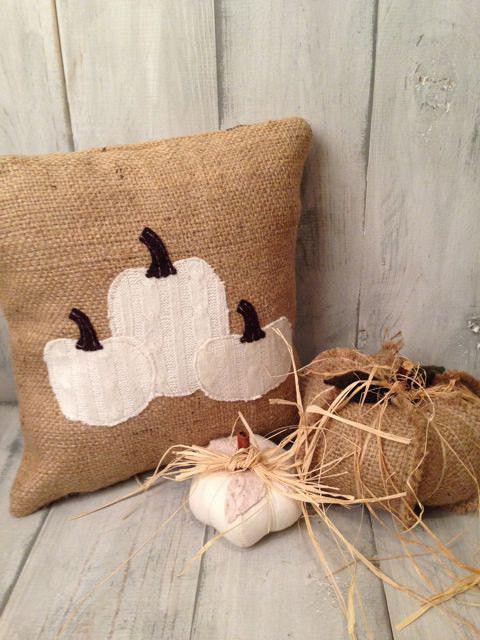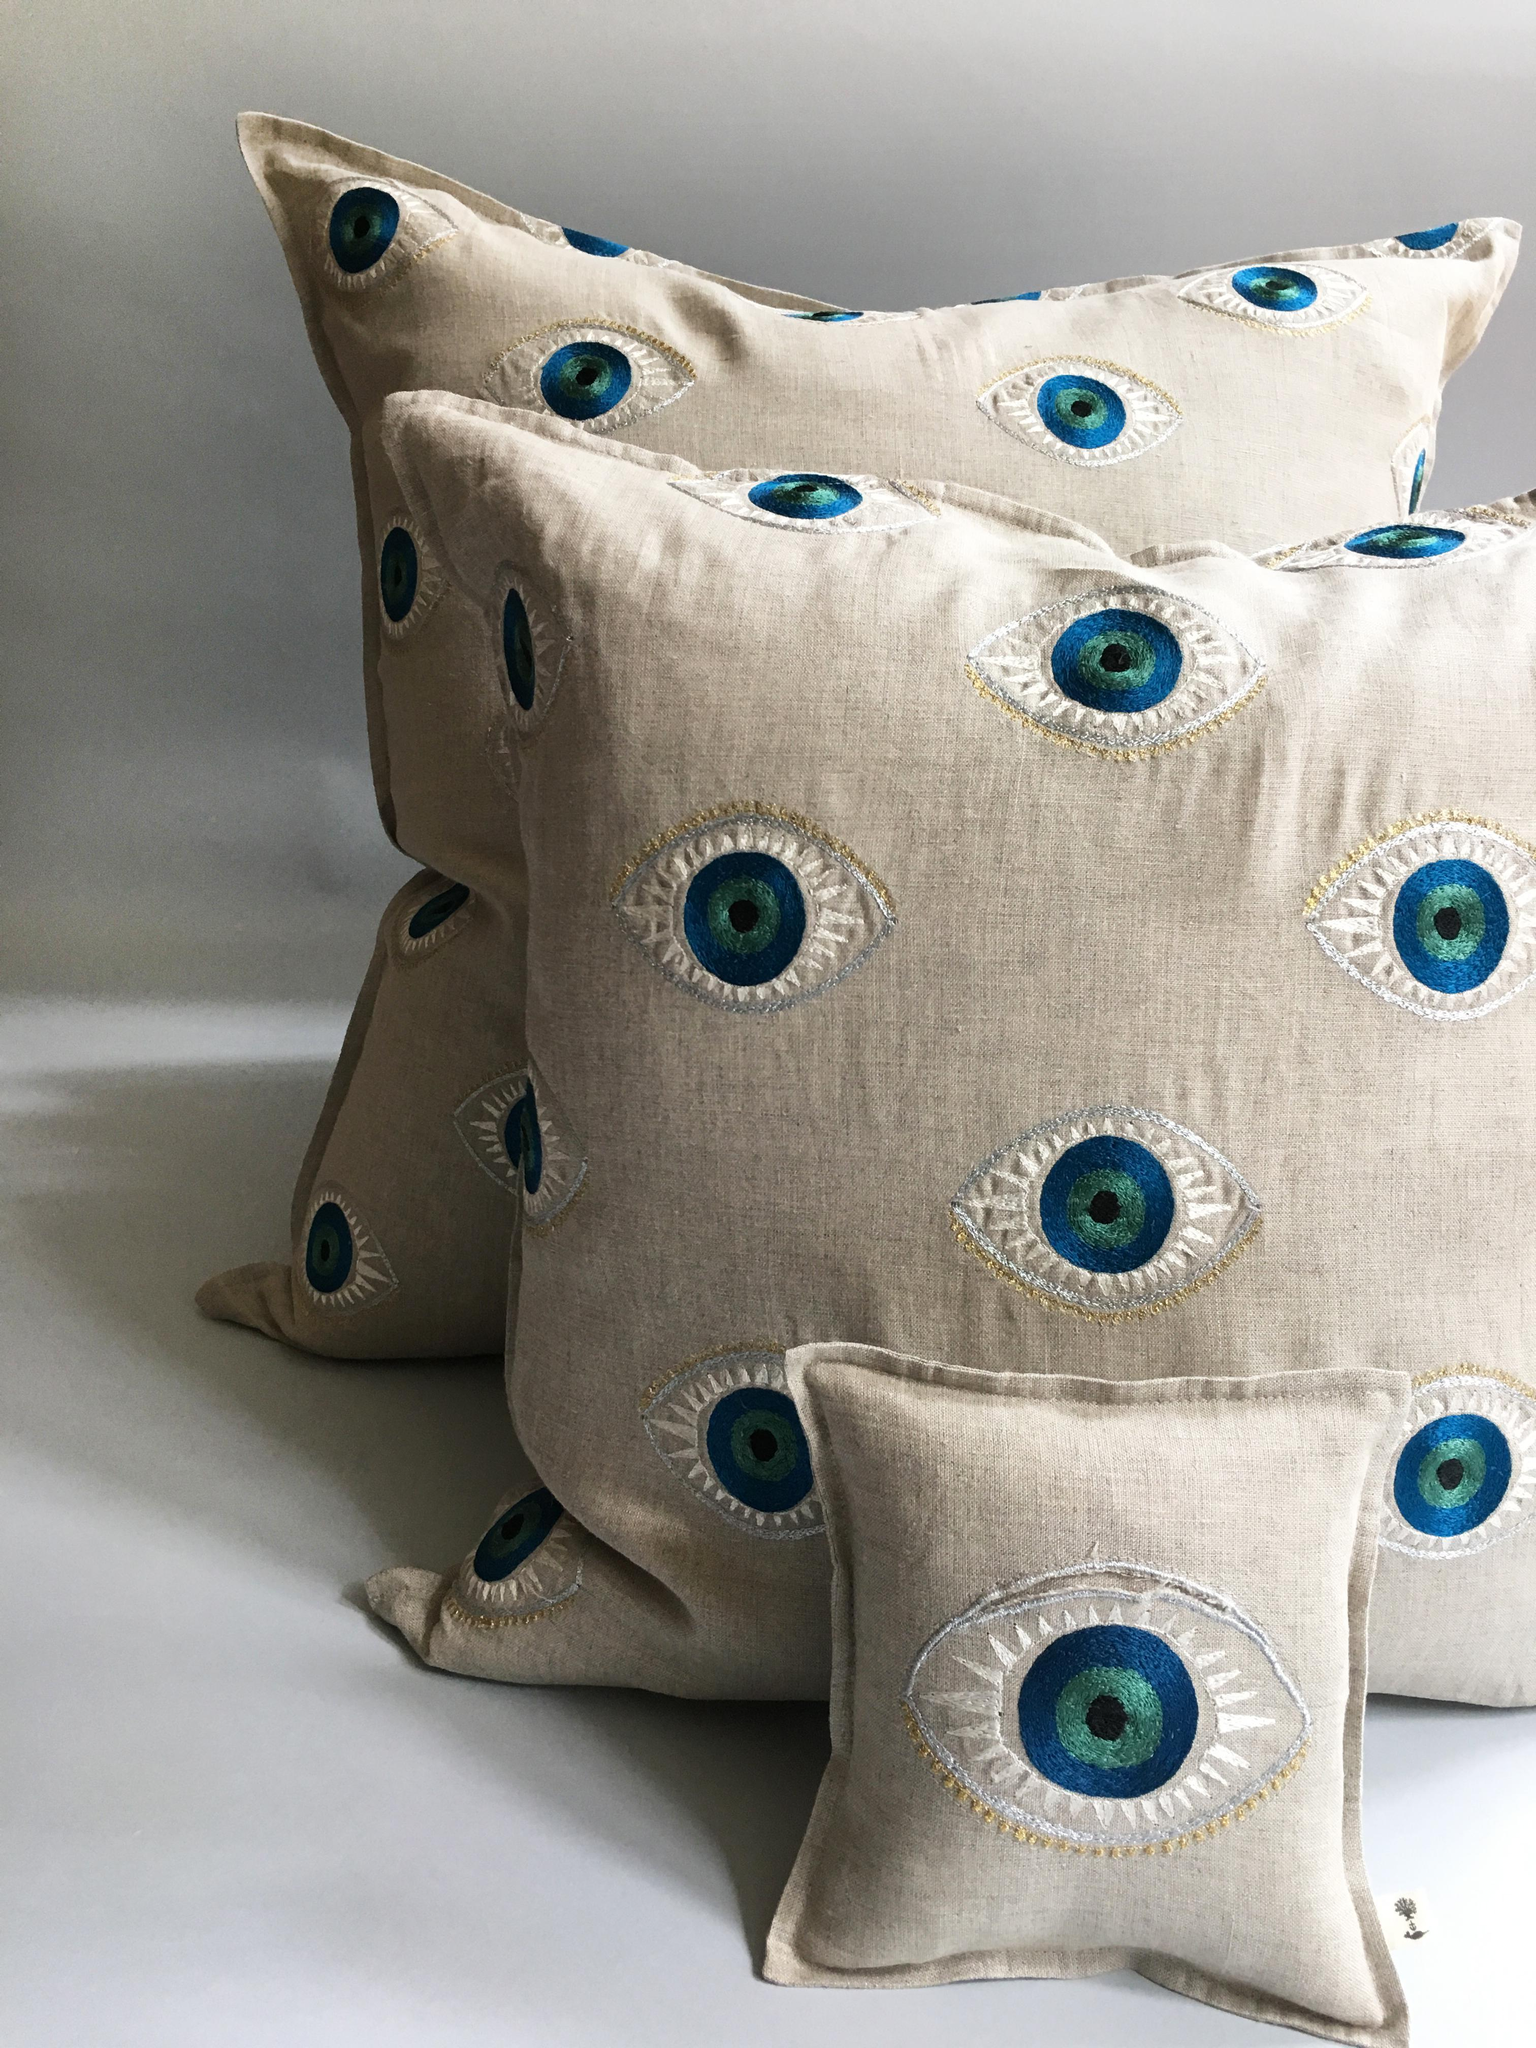The first image is the image on the left, the second image is the image on the right. Analyze the images presented: Is the assertion "An image shows one square pillow made of burlap decorated with pumpkin shapes." valid? Answer yes or no. Yes. The first image is the image on the left, the second image is the image on the right. Assess this claim about the two images: "A single burlap covered pillow sits on a wooden surface in the image on the left.". Correct or not? Answer yes or no. Yes. 